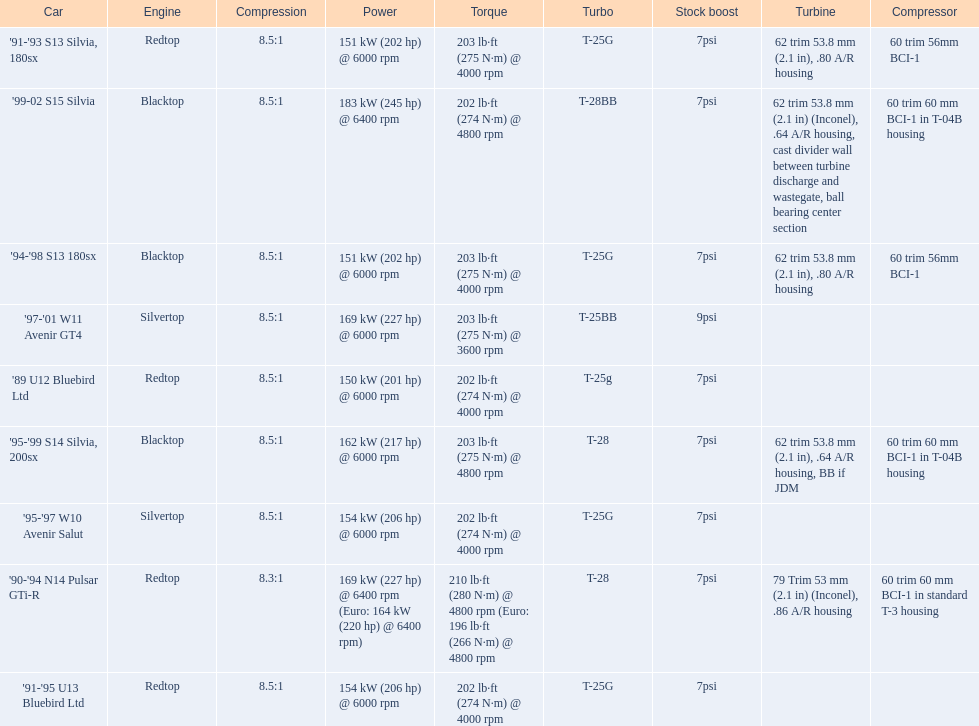Which cars featured blacktop engines? '94-'98 S13 180sx, '95-'99 S14 Silvia, 200sx, '99-02 S15 Silvia. Which of these had t-04b compressor housings? '95-'99 S14 Silvia, 200sx, '99-02 S15 Silvia. Which one of these has the highest horsepower? '99-02 S15 Silvia. 